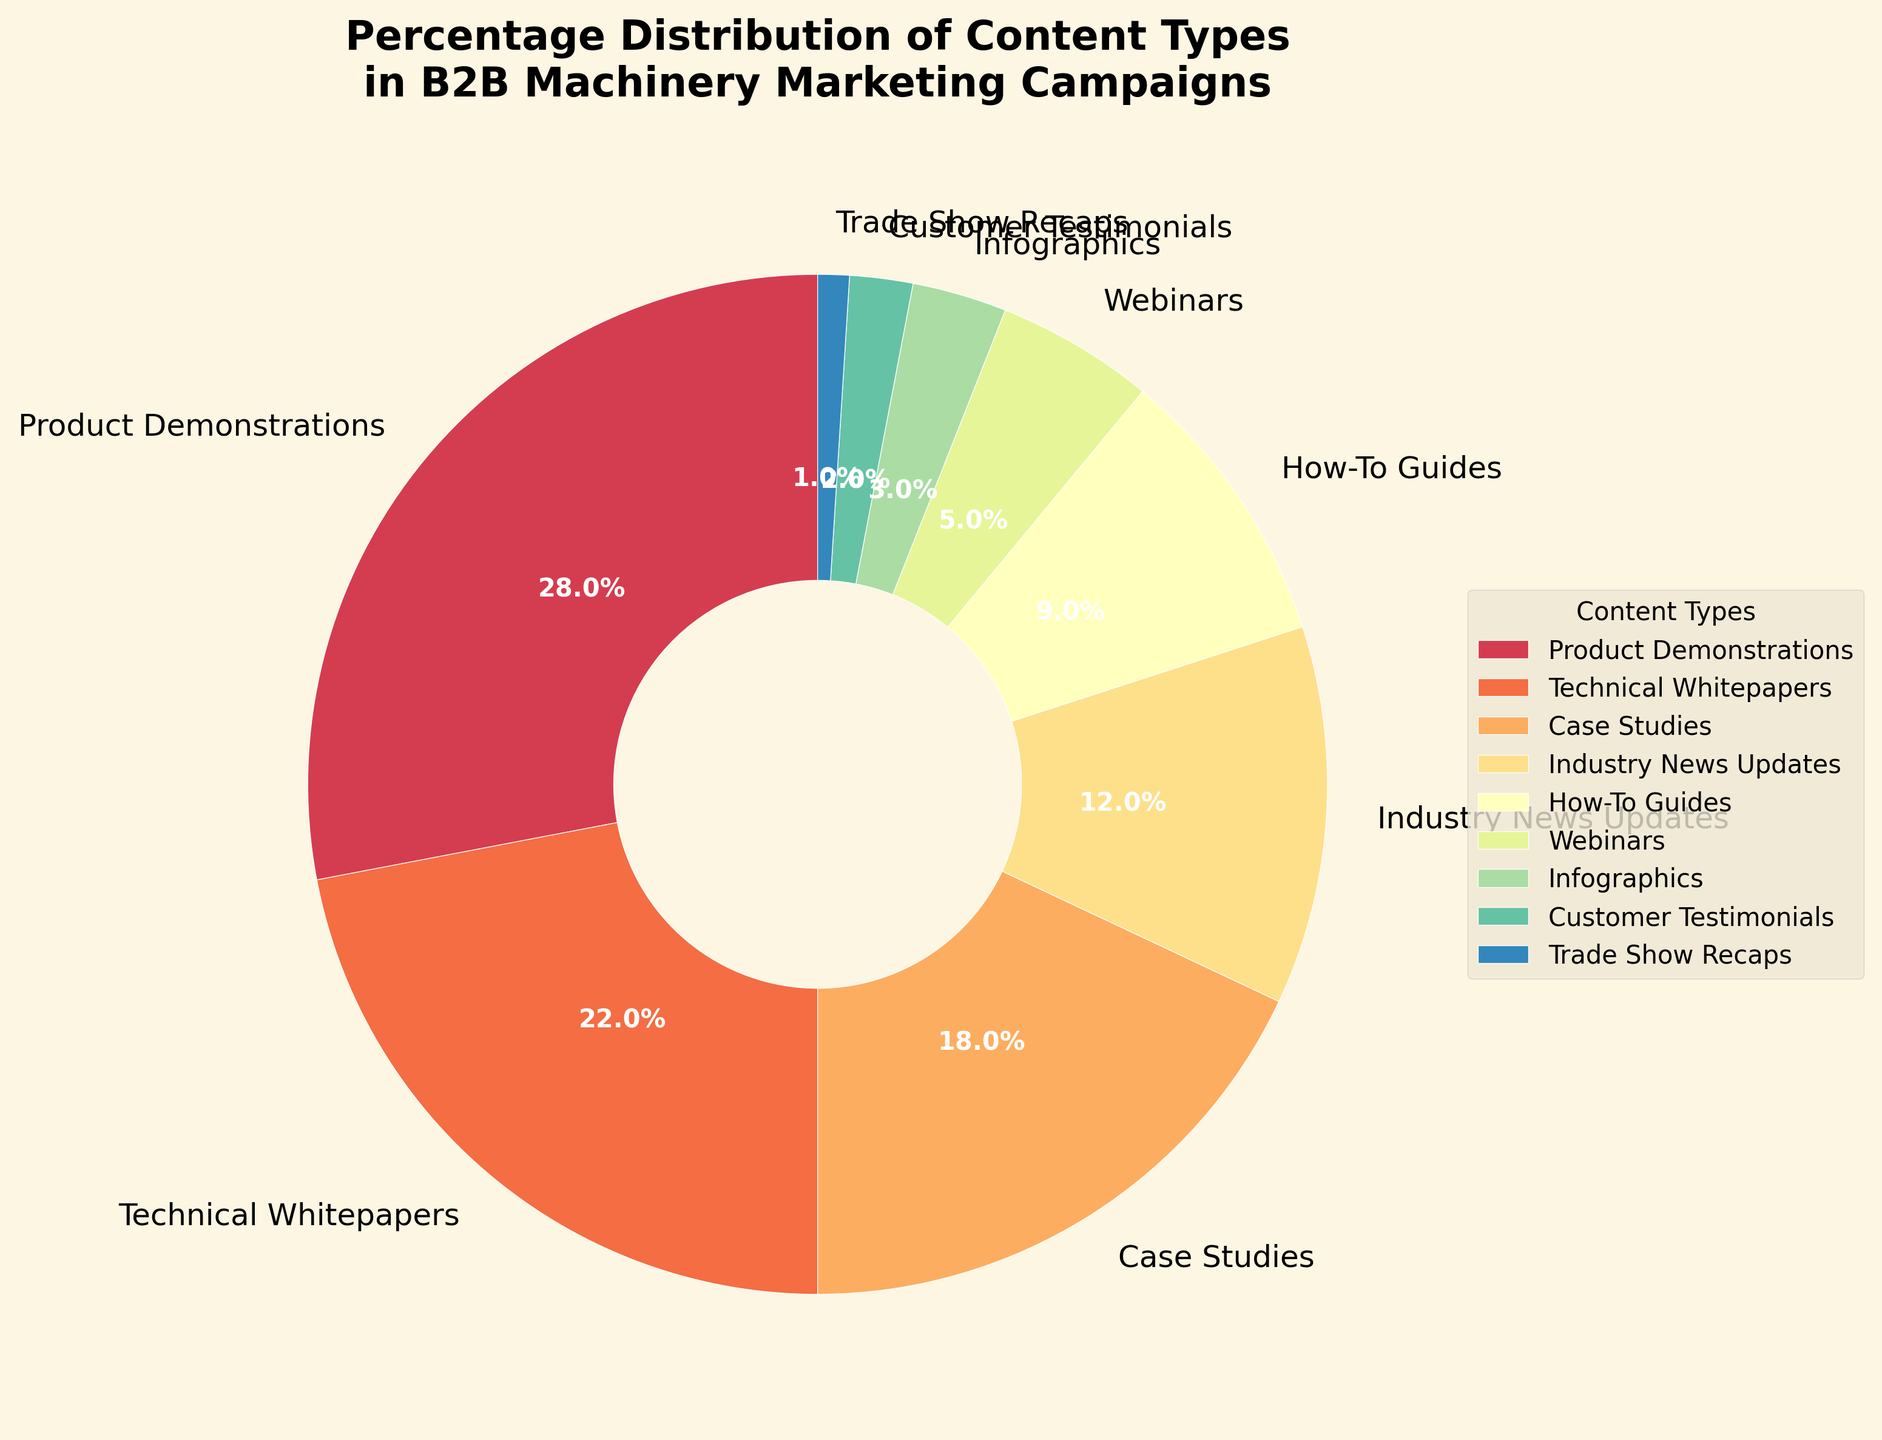Which content type has the highest percentage? The pie chart shows the percentage distribution of different content types. A quick glance identifies that Product Demonstrations has the largest section.
Answer: Product Demonstrations What is the combined percentage of Case Studies, How-To Guides, and Infographics? To find the combined percentage, sum the individual percentages: Case Studies (18%) + How-To Guides (9%) + Infographics (3%) = 18% + 9% + 3% = 30%
Answer: 30% Which content type is almost half of the percentage of Product Demonstrations? Product Demonstrations is 28%. The content type close to half of this percentage is Technical Whitepapers at 22%, because 22 is approximately half of 28.
Answer: Technical Whitepapers What is the difference in percentage between Industry News Updates and Webinars? Subtract the percentage of Webinars from Industry News Updates: 12% - 5% = 7%.
Answer: 7% How many content types have a percentage less than 10%? By checking each slice of the pie chart, we see How-To Guides (9%), Webinars (5%), Infographics (3%), Customer Testimonials (2%), and Trade Show Recaps (1%) all have percentages less than 10%. There are 5 content types.
Answer: 5 What is the second largest content type by percentage? By examining the pie chart, it's clear the second largest section is Technical Whitepapers at 22%.
Answer: Technical Whitepapers What percentage of the content types collectively contribute to the smallest three sections? The smallest three sections are Infographics (3%), Customer Testimonials (2%), and Trade Show Recaps (1%). Sum these percentages: 3% + 2% + 1% = 6%.
Answer: 6% Is the percentage of Product Demonstrations greater than the combined percentage of Webinars and Infographics? The percentage of Product Demonstrations is 28%. The combined percentages of Webinars (5%) and Infographics (3%) is 5% + 3% = 8%, which is less than 28%.
Answer: Yes Which segment uses a yellowish color in the pie chart? The color yellowish typically denotes one of the segments. By visually inspecting the chart, the yellowish color represents Case Studies.
Answer: Case Studies 